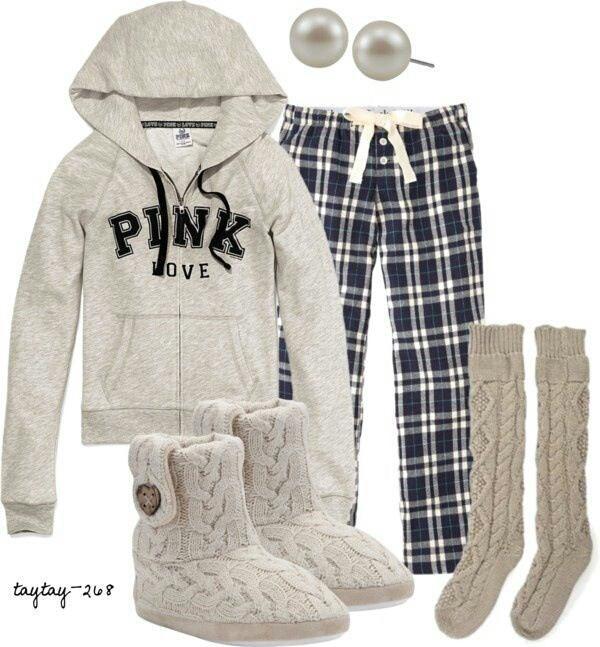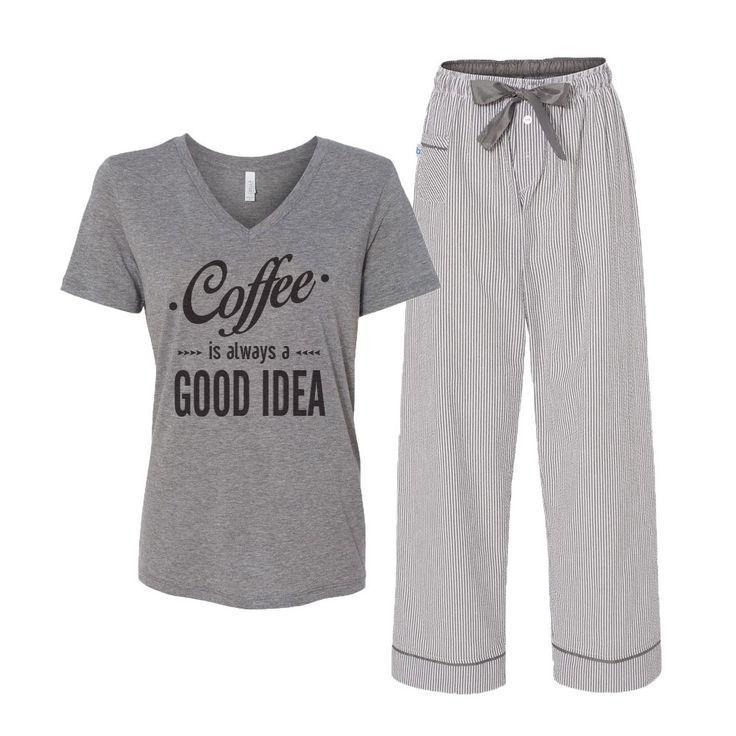The first image is the image on the left, the second image is the image on the right. Evaluate the accuracy of this statement regarding the images: "There is one outfit containing two articles of clothing per image.". Is it true? Answer yes or no. No. The first image is the image on the left, the second image is the image on the right. For the images shown, is this caption "At least one of the outfits features an animal-themed design." true? Answer yes or no. No. 